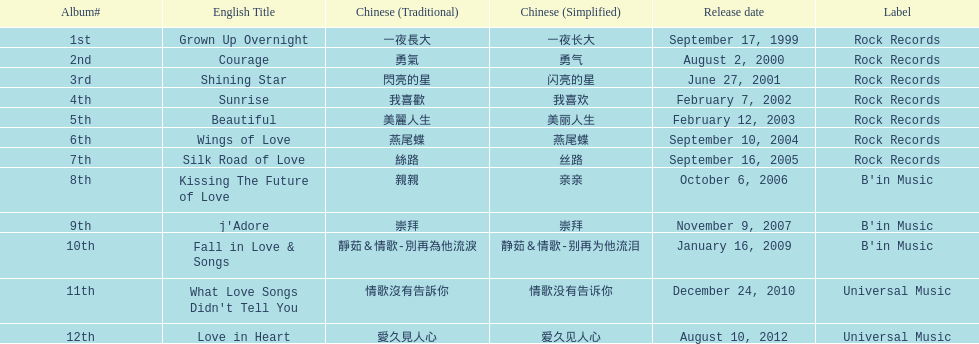Which album, released in an even-numbered year, was the only one by b'in music? Kissing The Future of Love. 